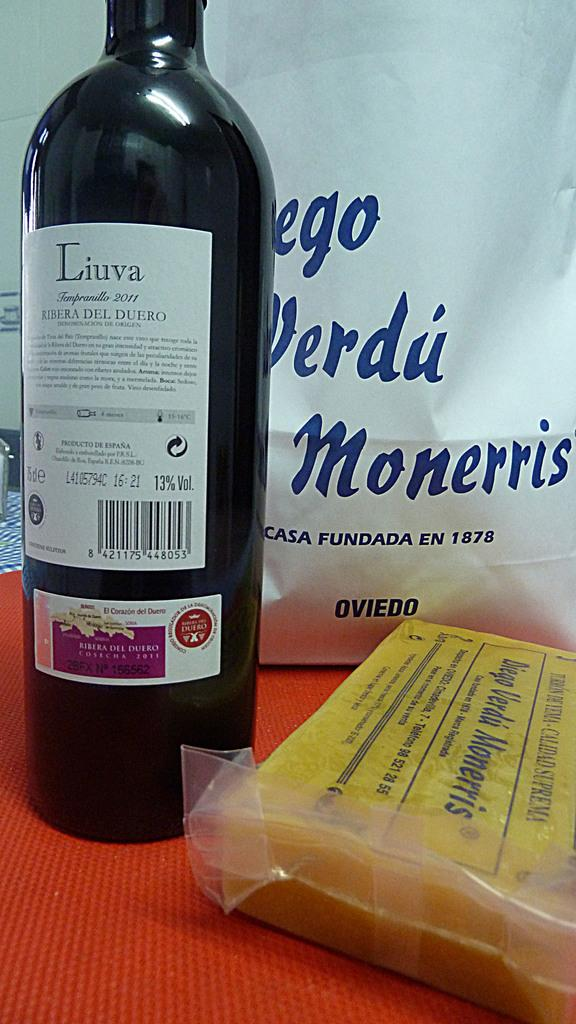<image>
Present a compact description of the photo's key features. A bottle that says Liuva on its label. 